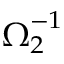<formula> <loc_0><loc_0><loc_500><loc_500>\Omega _ { 2 } ^ { - 1 }</formula> 